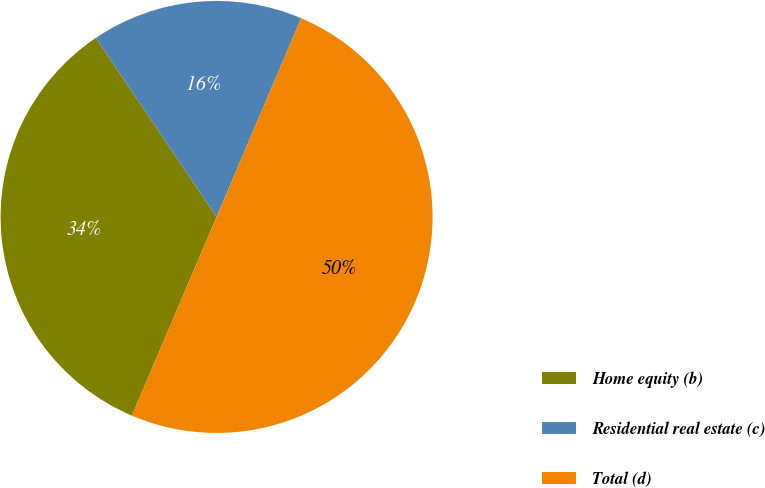Convert chart to OTSL. <chart><loc_0><loc_0><loc_500><loc_500><pie_chart><fcel>Home equity (b)<fcel>Residential real estate (c)<fcel>Total (d)<nl><fcel>34.15%<fcel>15.85%<fcel>50.0%<nl></chart> 